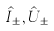Convert formula to latex. <formula><loc_0><loc_0><loc_500><loc_500>\hat { I } _ { \pm } , \hat { U } _ { \pm }</formula> 